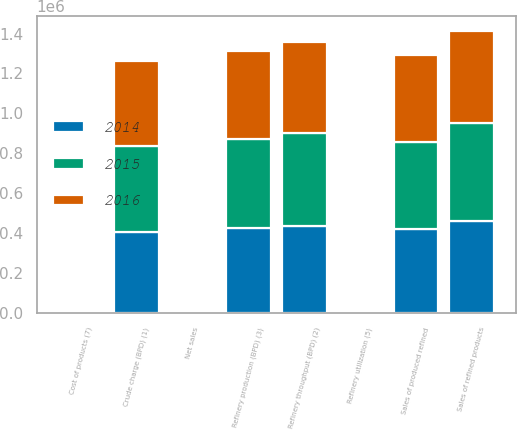<chart> <loc_0><loc_0><loc_500><loc_500><stacked_bar_chart><ecel><fcel>Crude charge (BPD) (1)<fcel>Refinery throughput (BPD) (2)<fcel>Refinery production (BPD) (3)<fcel>Sales of produced refined<fcel>Sales of refined products<fcel>Refinery utilization (5)<fcel>Net sales<fcel>Cost of products (7)<nl><fcel>2016<fcel>423910<fcel>457480<fcel>442110<fcel>435420<fcel>464980<fcel>92.8<fcel>58.02<fcel>49.64<nl><fcel>2015<fcel>432560<fcel>463580<fcel>446560<fcel>438000<fcel>488350<fcel>97.6<fcel>71.32<fcel>55.25<nl><fcel>2014<fcel>406180<fcel>436400<fcel>425010<fcel>420990<fcel>461640<fcel>91.7<fcel>110.19<fcel>96.21<nl></chart> 